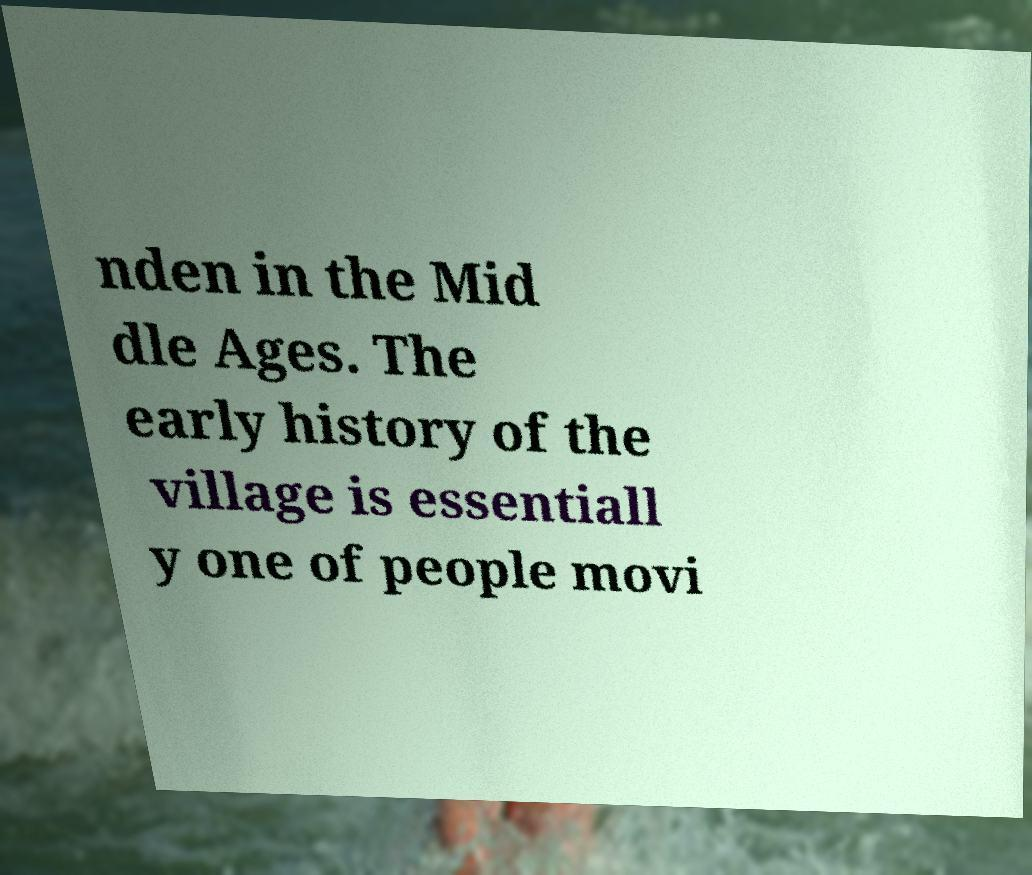Could you extract and type out the text from this image? nden in the Mid dle Ages. The early history of the village is essentiall y one of people movi 